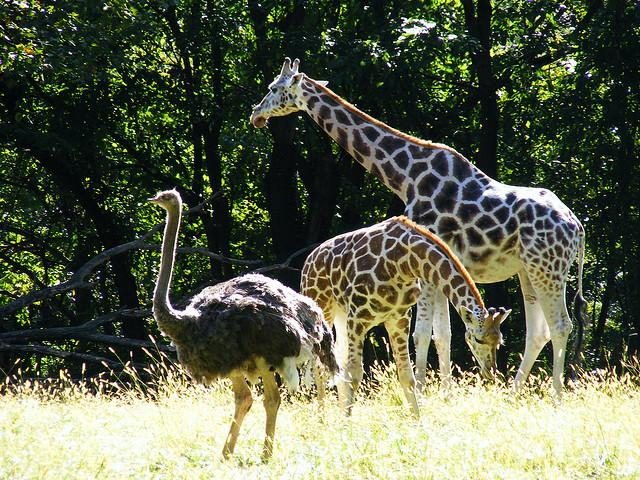How many giraffes are standing around the forest near the ostrich? Please explain your reasoning. two. There are two giraffes. 